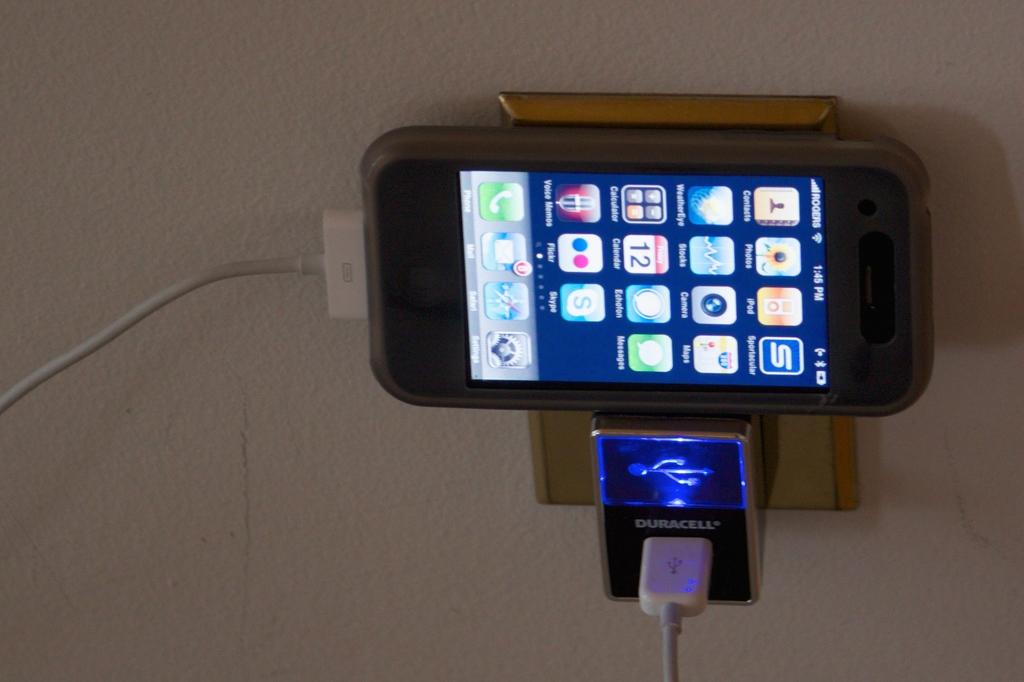What brand is the charging outlet?
Offer a terse response. Duracell. 